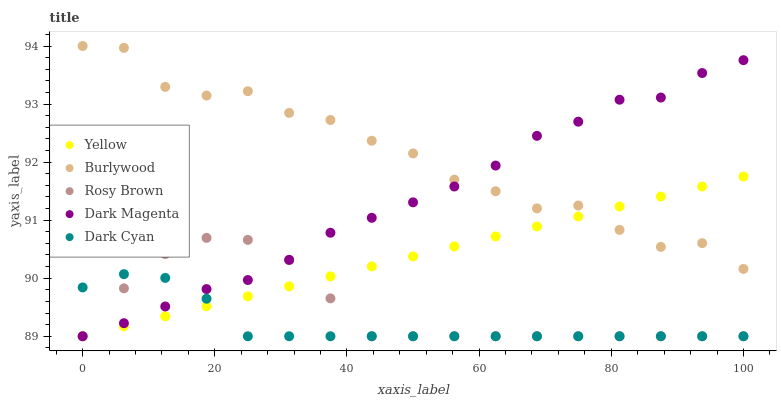Does Dark Cyan have the minimum area under the curve?
Answer yes or no. Yes. Does Burlywood have the maximum area under the curve?
Answer yes or no. Yes. Does Rosy Brown have the minimum area under the curve?
Answer yes or no. No. Does Rosy Brown have the maximum area under the curve?
Answer yes or no. No. Is Yellow the smoothest?
Answer yes or no. Yes. Is Burlywood the roughest?
Answer yes or no. Yes. Is Dark Cyan the smoothest?
Answer yes or no. No. Is Dark Cyan the roughest?
Answer yes or no. No. Does Dark Cyan have the lowest value?
Answer yes or no. Yes. Does Burlywood have the highest value?
Answer yes or no. Yes. Does Rosy Brown have the highest value?
Answer yes or no. No. Is Rosy Brown less than Burlywood?
Answer yes or no. Yes. Is Burlywood greater than Dark Cyan?
Answer yes or no. Yes. Does Rosy Brown intersect Dark Magenta?
Answer yes or no. Yes. Is Rosy Brown less than Dark Magenta?
Answer yes or no. No. Is Rosy Brown greater than Dark Magenta?
Answer yes or no. No. Does Rosy Brown intersect Burlywood?
Answer yes or no. No. 